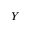Convert formula to latex. <formula><loc_0><loc_0><loc_500><loc_500>Y</formula> 